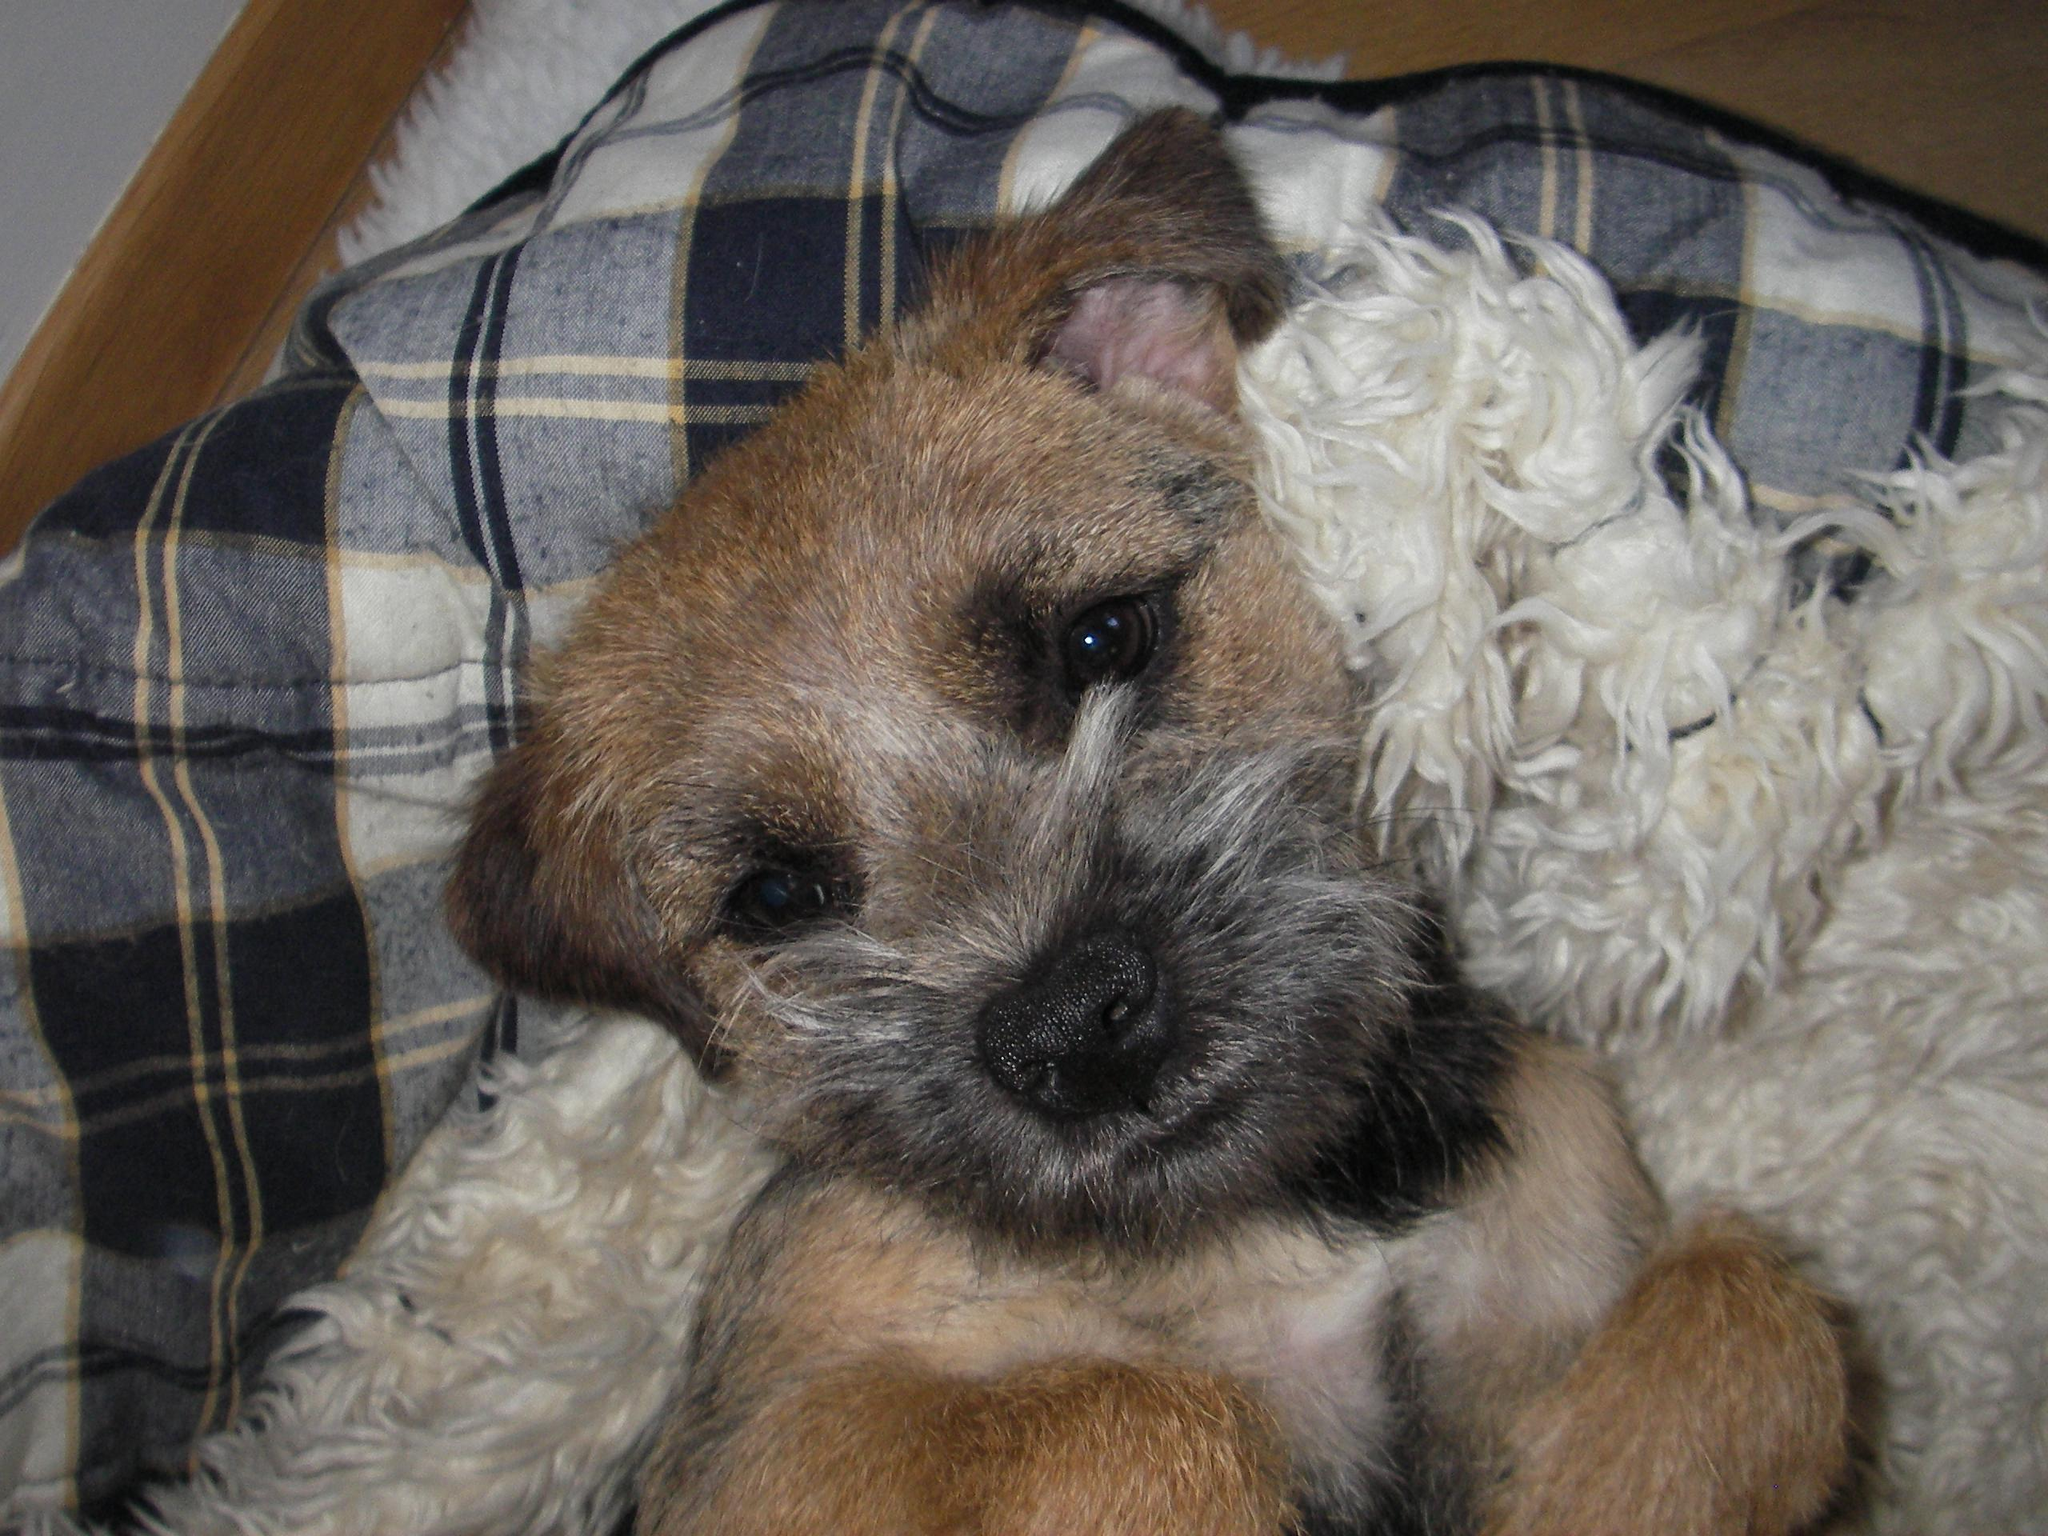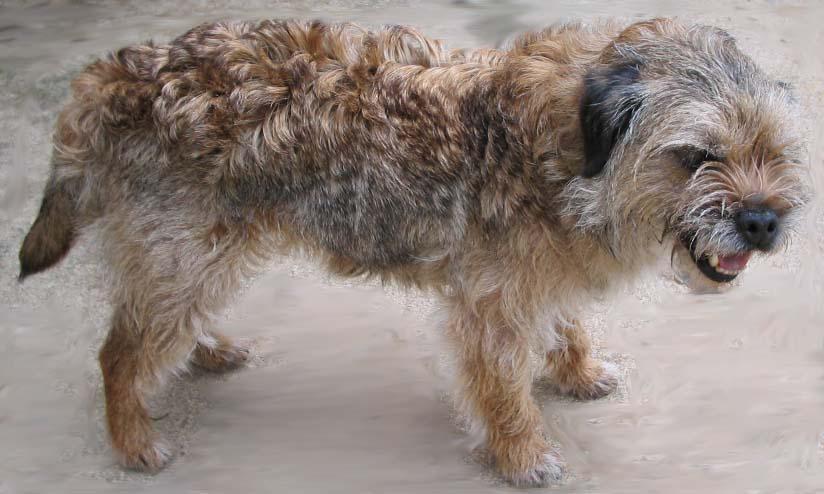The first image is the image on the left, the second image is the image on the right. Assess this claim about the two images: "There is a single dog with it's tongue slightly visible in the right image.". Correct or not? Answer yes or no. Yes. 